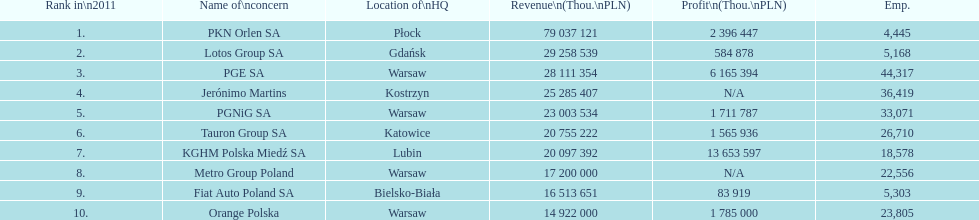What company has the top number of employees? PGE SA. 